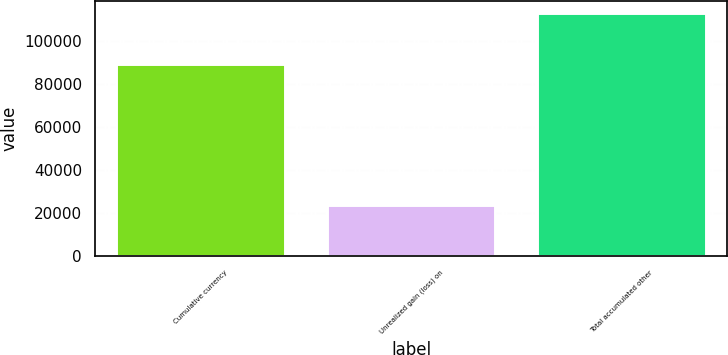Convert chart. <chart><loc_0><loc_0><loc_500><loc_500><bar_chart><fcel>Cumulative currency<fcel>Unrealized gain (loss) on<fcel>Total accumulated other<nl><fcel>89289<fcel>23888<fcel>113177<nl></chart> 